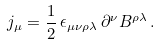<formula> <loc_0><loc_0><loc_500><loc_500>j _ { \mu } = \frac { 1 } { 2 } \, \epsilon _ { \mu \nu \rho \lambda } \, \partial ^ { \nu } B ^ { \rho \lambda } \, .</formula> 